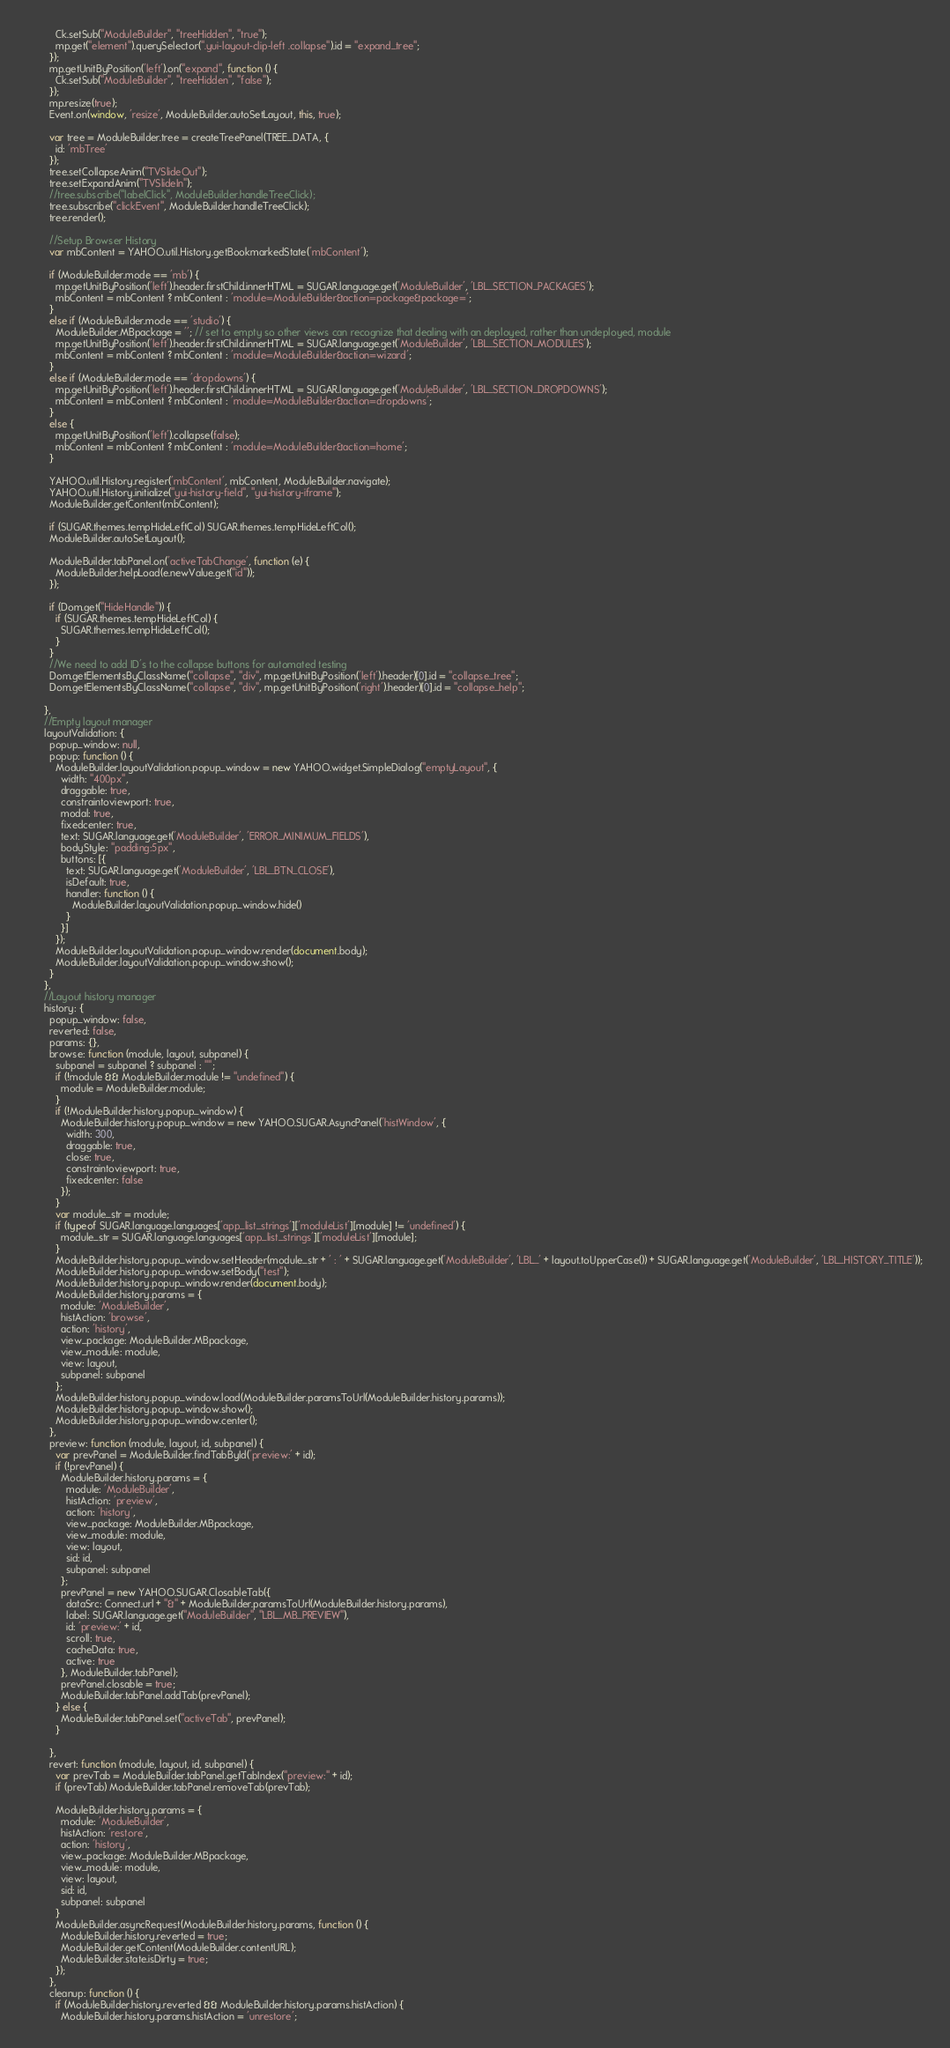Convert code to text. <code><loc_0><loc_0><loc_500><loc_500><_JavaScript_>          Ck.setSub("ModuleBuilder", "treeHidden", "true");
          mp.get("element").querySelector(".yui-layout-clip-left .collapse").id = "expand_tree";
        });
        mp.getUnitByPosition('left').on("expand", function () {
          Ck.setSub("ModuleBuilder", "treeHidden", "false");
        });
        mp.resize(true);
        Event.on(window, 'resize', ModuleBuilder.autoSetLayout, this, true);

        var tree = ModuleBuilder.tree = createTreePanel(TREE_DATA, {
          id: 'mbTree'
        });
        tree.setCollapseAnim("TVSlideOut");
        tree.setExpandAnim("TVSlideIn");
        //tree.subscribe("labelClick", ModuleBuilder.handleTreeClick);
        tree.subscribe("clickEvent", ModuleBuilder.handleTreeClick);
        tree.render();

        //Setup Browser History
        var mbContent = YAHOO.util.History.getBookmarkedState('mbContent');

        if (ModuleBuilder.mode == 'mb') {
          mp.getUnitByPosition('left').header.firstChild.innerHTML = SUGAR.language.get('ModuleBuilder', 'LBL_SECTION_PACKAGES');
          mbContent = mbContent ? mbContent : 'module=ModuleBuilder&action=package&package=';
        }
        else if (ModuleBuilder.mode == 'studio') {
          ModuleBuilder.MBpackage = ''; // set to empty so other views can recognize that dealing with an deployed, rather than undeployed, module
          mp.getUnitByPosition('left').header.firstChild.innerHTML = SUGAR.language.get('ModuleBuilder', 'LBL_SECTION_MODULES');
          mbContent = mbContent ? mbContent : 'module=ModuleBuilder&action=wizard';
        }
        else if (ModuleBuilder.mode == 'dropdowns') {
          mp.getUnitByPosition('left').header.firstChild.innerHTML = SUGAR.language.get('ModuleBuilder', 'LBL_SECTION_DROPDOWNS');
          mbContent = mbContent ? mbContent : 'module=ModuleBuilder&action=dropdowns';
        }
        else {
          mp.getUnitByPosition('left').collapse(false);
          mbContent = mbContent ? mbContent : 'module=ModuleBuilder&action=home';
        }

        YAHOO.util.History.register('mbContent', mbContent, ModuleBuilder.navigate);
        YAHOO.util.History.initialize("yui-history-field", "yui-history-iframe");
        ModuleBuilder.getContent(mbContent);

        if (SUGAR.themes.tempHideLeftCol) SUGAR.themes.tempHideLeftCol();
        ModuleBuilder.autoSetLayout();

        ModuleBuilder.tabPanel.on('activeTabChange', function (e) {
          ModuleBuilder.helpLoad(e.newValue.get("id"));
        });

        if (Dom.get("HideHandle")) {
          if (SUGAR.themes.tempHideLeftCol) {
            SUGAR.themes.tempHideLeftCol();
          }
        }
        //We need to add ID's to the collapse buttons for automated testing
        Dom.getElementsByClassName("collapse", "div", mp.getUnitByPosition('left').header)[0].id = "collapse_tree";
        Dom.getElementsByClassName("collapse", "div", mp.getUnitByPosition('right').header)[0].id = "collapse_help";

      },
      //Empty layout manager
      layoutValidation: {
        popup_window: null,
        popup: function () {
          ModuleBuilder.layoutValidation.popup_window = new YAHOO.widget.SimpleDialog("emptyLayout", {
            width: "400px",
            draggable: true,
            constraintoviewport: true,
            modal: true,
            fixedcenter: true,
            text: SUGAR.language.get('ModuleBuilder', 'ERROR_MINIMUM_FIELDS'),
            bodyStyle: "padding:5px",
            buttons: [{
              text: SUGAR.language.get('ModuleBuilder', 'LBL_BTN_CLOSE'),
              isDefault: true,
              handler: function () {
                ModuleBuilder.layoutValidation.popup_window.hide()
              }
            }]
          });
          ModuleBuilder.layoutValidation.popup_window.render(document.body);
          ModuleBuilder.layoutValidation.popup_window.show();
        }
      },
      //Layout history manager
      history: {
        popup_window: false,
        reverted: false,
        params: {},
        browse: function (module, layout, subpanel) {
          subpanel = subpanel ? subpanel : "";
          if (!module && ModuleBuilder.module != "undefined") {
            module = ModuleBuilder.module;
          }
          if (!ModuleBuilder.history.popup_window) {
            ModuleBuilder.history.popup_window = new YAHOO.SUGAR.AsyncPanel('histWindow', {
              width: 300,
              draggable: true,
              close: true,
              constraintoviewport: true,
              fixedcenter: false
            });
          }
          var module_str = module;
          if (typeof SUGAR.language.languages['app_list_strings']['moduleList'][module] != 'undefined') {
            module_str = SUGAR.language.languages['app_list_strings']['moduleList'][module];
          }
          ModuleBuilder.history.popup_window.setHeader(module_str + ' : ' + SUGAR.language.get('ModuleBuilder', 'LBL_' + layout.toUpperCase()) + SUGAR.language.get('ModuleBuilder', 'LBL_HISTORY_TITLE'));
          ModuleBuilder.history.popup_window.setBody("test");
          ModuleBuilder.history.popup_window.render(document.body);
          ModuleBuilder.history.params = {
            module: 'ModuleBuilder',
            histAction: 'browse',
            action: 'history',
            view_package: ModuleBuilder.MBpackage,
            view_module: module,
            view: layout,
            subpanel: subpanel
          };
          ModuleBuilder.history.popup_window.load(ModuleBuilder.paramsToUrl(ModuleBuilder.history.params));
          ModuleBuilder.history.popup_window.show();
          ModuleBuilder.history.popup_window.center();
        },
        preview: function (module, layout, id, subpanel) {
          var prevPanel = ModuleBuilder.findTabById('preview:' + id);
          if (!prevPanel) {
            ModuleBuilder.history.params = {
              module: 'ModuleBuilder',
              histAction: 'preview',
              action: 'history',
              view_package: ModuleBuilder.MBpackage,
              view_module: module,
              view: layout,
              sid: id,
              subpanel: subpanel
            };
            prevPanel = new YAHOO.SUGAR.ClosableTab({
              dataSrc: Connect.url + "&" + ModuleBuilder.paramsToUrl(ModuleBuilder.history.params),
              label: SUGAR.language.get("ModuleBuilder", "LBL_MB_PREVIEW"),
              id: 'preview:' + id,
              scroll: true,
              cacheData: true,
              active: true
            }, ModuleBuilder.tabPanel);
            prevPanel.closable = true;
            ModuleBuilder.tabPanel.addTab(prevPanel);
          } else {
            ModuleBuilder.tabPanel.set("activeTab", prevPanel);
          }

        },
        revert: function (module, layout, id, subpanel) {
          var prevTab = ModuleBuilder.tabPanel.getTabIndex("preview:" + id);
          if (prevTab) ModuleBuilder.tabPanel.removeTab(prevTab);

          ModuleBuilder.history.params = {
            module: 'ModuleBuilder',
            histAction: 'restore',
            action: 'history',
            view_package: ModuleBuilder.MBpackage,
            view_module: module,
            view: layout,
            sid: id,
            subpanel: subpanel
          }
          ModuleBuilder.asyncRequest(ModuleBuilder.history.params, function () {
            ModuleBuilder.history.reverted = true;
            ModuleBuilder.getContent(ModuleBuilder.contentURL);
            ModuleBuilder.state.isDirty = true;
          });
        },
        cleanup: function () {
          if (ModuleBuilder.history.reverted && ModuleBuilder.history.params.histAction) {
            ModuleBuilder.history.params.histAction = 'unrestore';</code> 